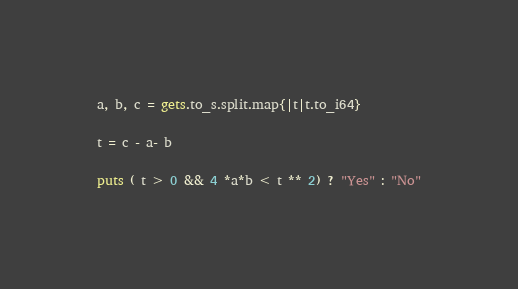<code> <loc_0><loc_0><loc_500><loc_500><_Crystal_>a, b, c = gets.to_s.split.map{|t|t.to_i64}

t = c - a- b

puts ( t > 0 && 4 *a*b < t ** 2) ? "Yes" : "No"</code> 